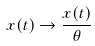Convert formula to latex. <formula><loc_0><loc_0><loc_500><loc_500>x ( t ) \to \frac { x ( t ) } { \theta }</formula> 